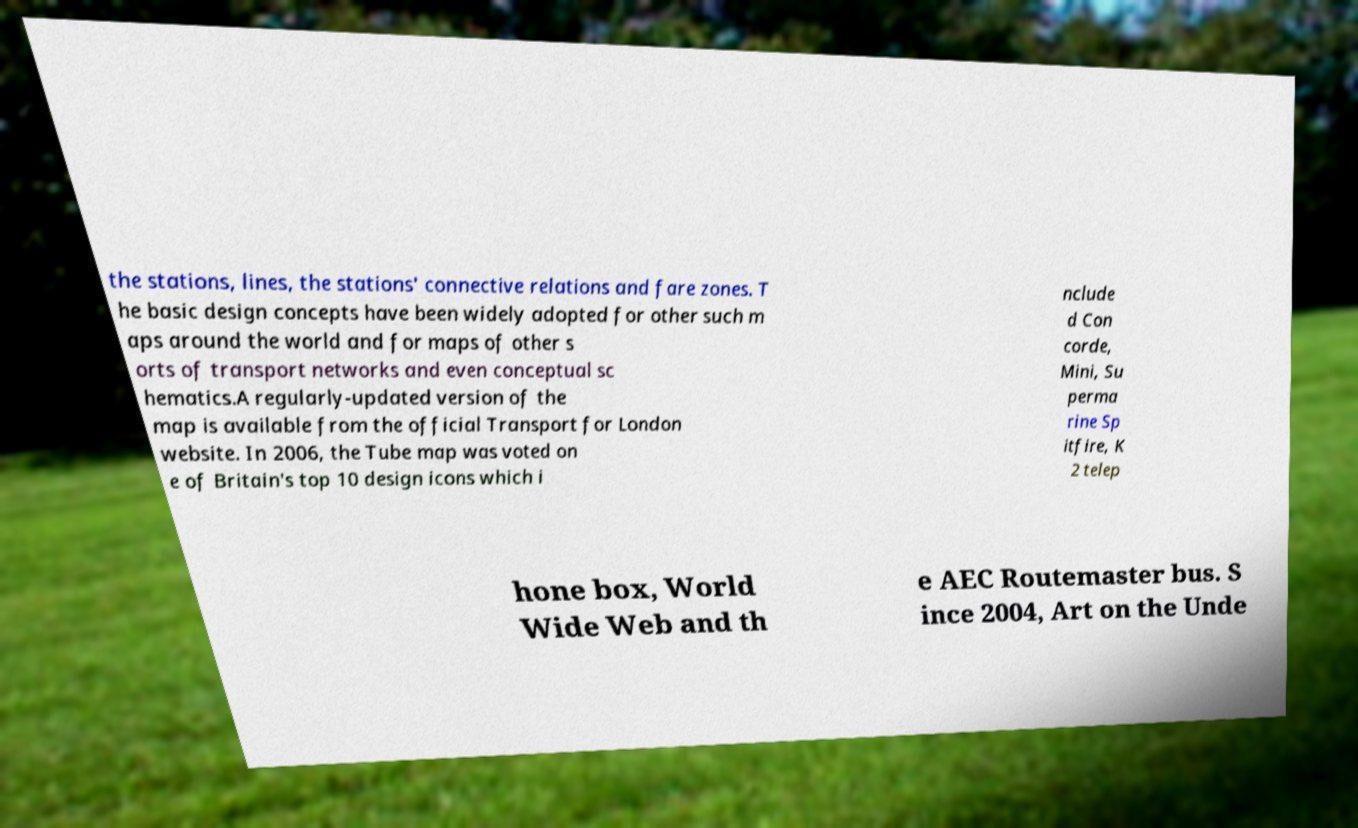Please read and relay the text visible in this image. What does it say? the stations, lines, the stations' connective relations and fare zones. T he basic design concepts have been widely adopted for other such m aps around the world and for maps of other s orts of transport networks and even conceptual sc hematics.A regularly-updated version of the map is available from the official Transport for London website. In 2006, the Tube map was voted on e of Britain's top 10 design icons which i nclude d Con corde, Mini, Su perma rine Sp itfire, K 2 telep hone box, World Wide Web and th e AEC Routemaster bus. S ince 2004, Art on the Unde 